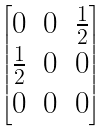Convert formula to latex. <formula><loc_0><loc_0><loc_500><loc_500>\begin{bmatrix} 0 & 0 & \frac { 1 } { 2 } \\ \frac { 1 } { 2 } & 0 & 0 \\ 0 & 0 & 0 \end{bmatrix}</formula> 